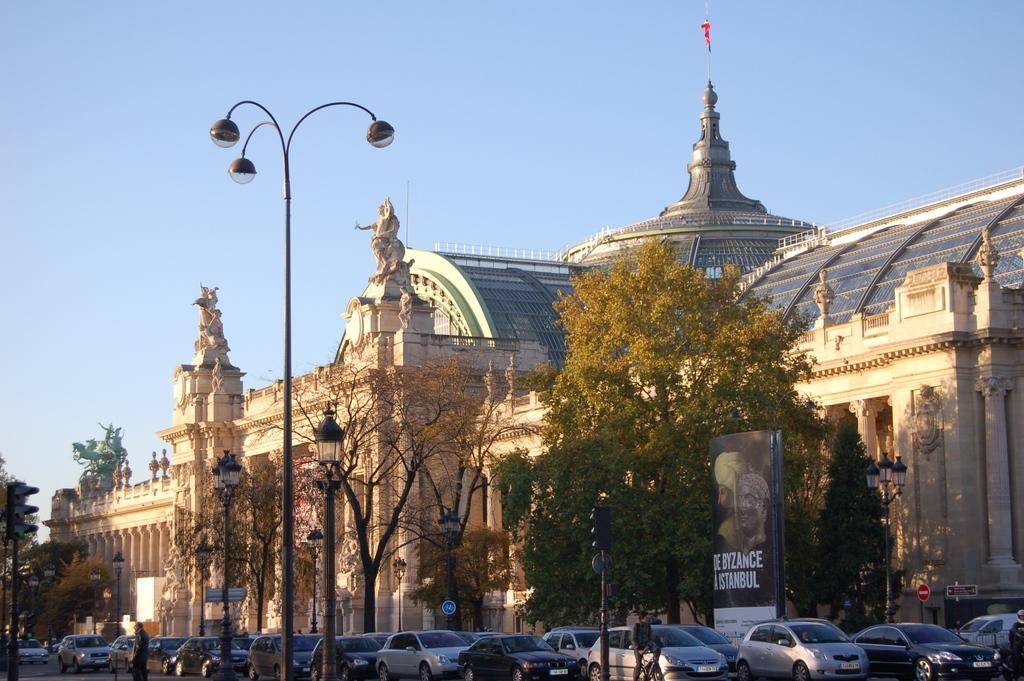In one or two sentences, can you explain what this image depicts? There are vehicles on the road. Here we can see poles, lights, trees, boards, hoarding, buildings, and few persons. In the background there is sky. 